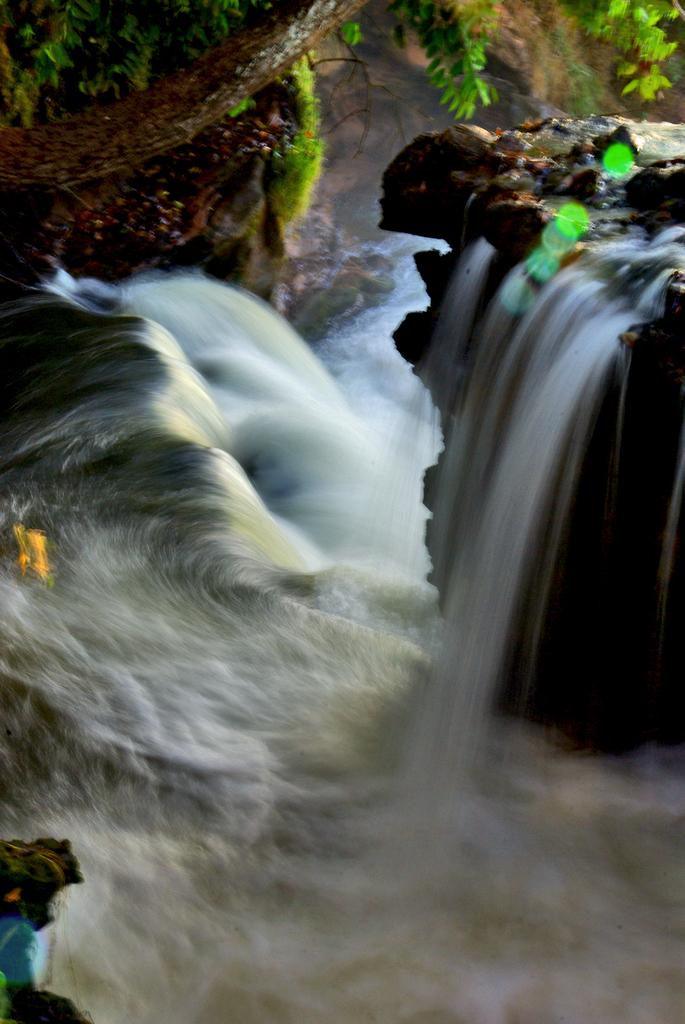What natural feature is the main subject of the picture? There is a waterfall in the picture. What type of vegetation can be seen in the background of the picture? There is a tree at the back of the picture. What is visible at the bottom of the picture? There is water visible at the bottom of the picture. How many legs can be seen on the bead in the picture? There is no bead present in the picture, so it is not possible to determine the number of legs on a bead. 